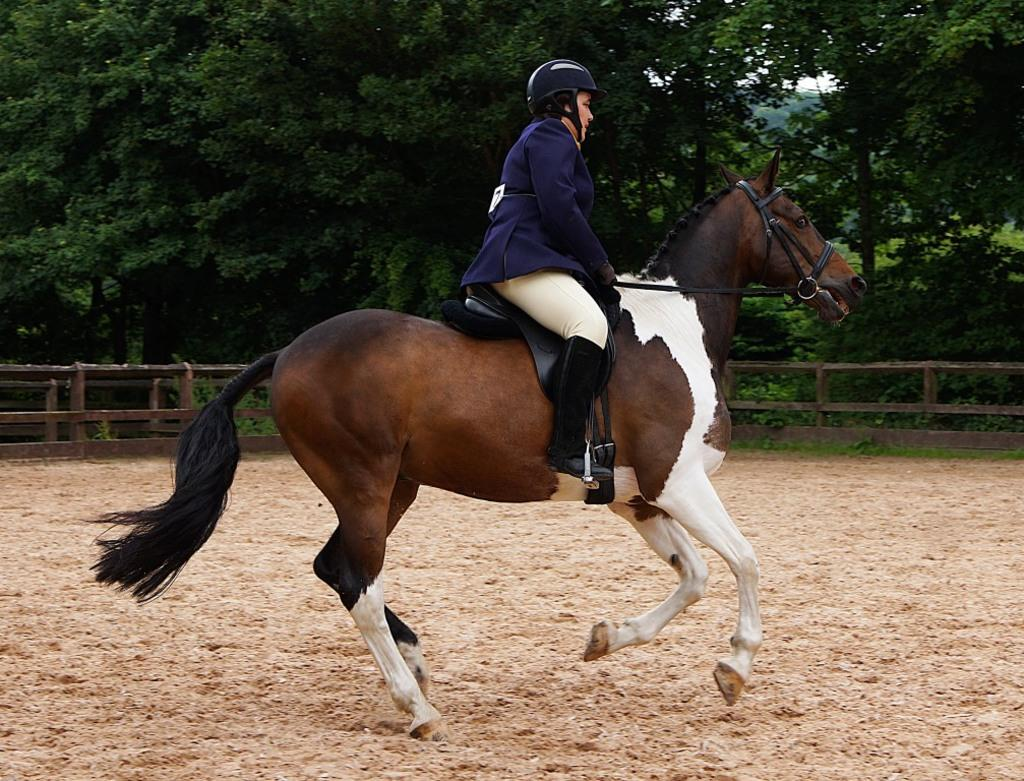What is the person in the image doing? The person is riding a horse in the image. What is the person wearing while riding the horse? The person is wearing a helmet. What is the horse's position in the image? The horse is on the ground. What can be seen in the background of the image? There are trees and a fence in the background of the image. What time of day is it in the image, and what color is the cub? The time of day is not mentioned in the image, and there is no cub present in the image. 